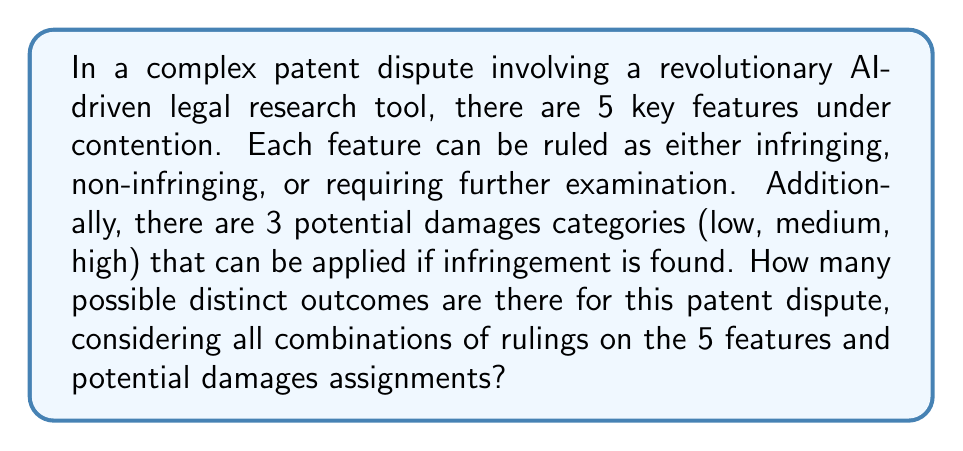Can you solve this math problem? Let's approach this problem step-by-step using combinatorics:

1) First, let's consider the possible outcomes for each feature:
   - Each feature has 3 possible rulings: infringing, non-infringing, or requiring further examination.
   - There are 5 features in total.
   - This is a case of independent choices, so we use the multiplication principle.
   - The number of possible combinations for feature rulings is $3^5$.

2) Now, let's consider the damages:
   - Damages only apply to features ruled as infringing.
   - For each infringing feature, there are 3 possible damage categories.
   - We need to consider all possible numbers of infringing features, from 0 to 5.

3) Let's break it down by the number of infringing features:
   - 0 infringing features: only 1 way (no damages)
   - 1 infringing feature: $\binom{5}{1} \cdot 3^1$ ways
   - 2 infringing features: $\binom{5}{2} \cdot 3^2$ ways
   - 3 infringing features: $\binom{5}{3} \cdot 3^3$ ways
   - 4 infringing features: $\binom{5}{4} \cdot 3^4$ ways
   - 5 infringing features: $\binom{5}{5} \cdot 3^5$ ways

4) The total number of outcomes is the sum of all these possibilities:

   $$\sum_{k=0}^5 \binom{5}{k} \cdot 3^k$$

5) Let's calculate this sum:
   $1 + 5 \cdot 3^1 + 10 \cdot 3^2 + 10 \cdot 3^3 + 5 \cdot 3^4 + 1 \cdot 3^5$
   $= 1 + 15 + 90 + 270 + 405 + 243 = 1024$

Therefore, there are 1024 possible distinct outcomes for this patent dispute.
Answer: 1024 possible distinct outcomes 